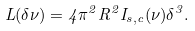<formula> <loc_0><loc_0><loc_500><loc_500>L ( \delta \nu ) = 4 \pi ^ { 2 } R ^ { 2 } I _ { s , c } ( \nu ) \delta ^ { 3 } .</formula> 